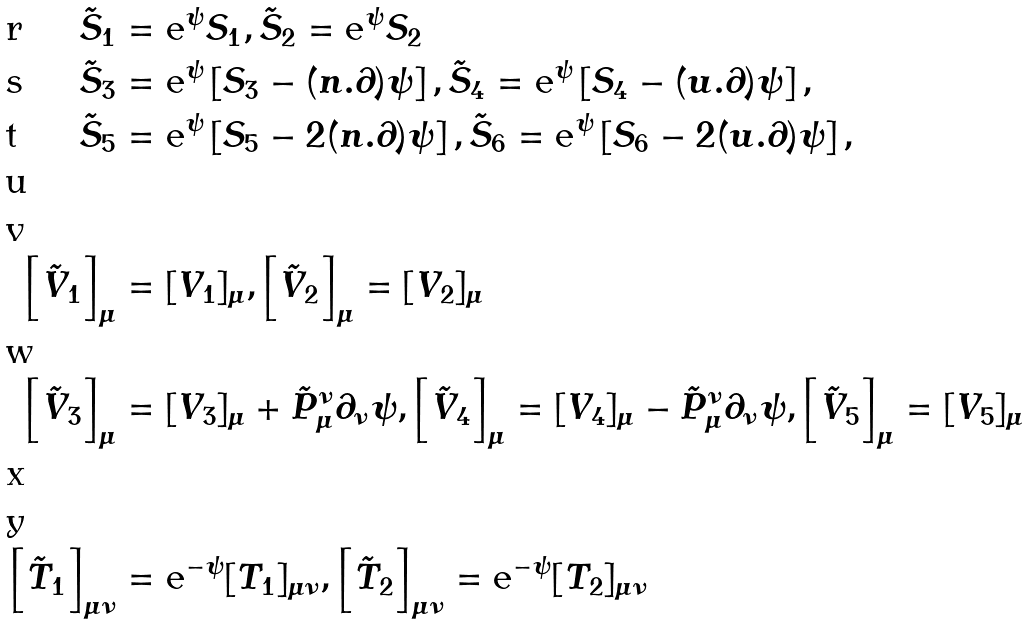Convert formula to latex. <formula><loc_0><loc_0><loc_500><loc_500>\tilde { S } _ { 1 } & = \text {e} ^ { \psi } S _ { 1 } , \tilde { S } _ { 2 } = \text {e} ^ { \psi } S _ { 2 } \\ \tilde { S } _ { 3 } & = \text {e} ^ { \psi } \left [ S _ { 3 } - ( n . \partial ) \psi \right ] , \tilde { S } _ { 4 } = \text {e} ^ { \psi } \left [ S _ { 4 } - ( u . \partial ) \psi \right ] , \\ \tilde { S } _ { 5 } & = \text {e} ^ { \psi } \left [ S _ { 5 } - 2 ( n . \partial ) \psi \right ] , \tilde { S } _ { 6 } = \text {e} ^ { \psi } \left [ S _ { 6 } - 2 ( u . \partial ) \psi \right ] , \\ \\ \left [ \tilde { V } _ { 1 } \right ] _ { \mu } & = [ V _ { 1 } ] _ { \mu } , \left [ \tilde { V } _ { 2 } \right ] _ { \mu } = [ V _ { 2 } ] _ { \mu } \\ \left [ \tilde { V } _ { 3 } \right ] _ { \mu } & = [ V _ { 3 } ] _ { \mu } + \tilde { P } ^ { \nu } _ { \mu } \partial _ { \nu } \psi , \left [ \tilde { V } _ { 4 } \right ] _ { \mu } = [ V _ { 4 } ] _ { \mu } - \tilde { P } ^ { \nu } _ { \mu } \partial _ { \nu } \psi , \left [ \tilde { V } _ { 5 } \right ] _ { \mu } = [ V _ { 5 } ] _ { \mu } \\ \\ \left [ \tilde { T } _ { 1 } \right ] _ { \mu \nu } & = \text {e} ^ { - \psi } [ T _ { 1 } ] _ { \mu \nu } , \left [ \tilde { T } _ { 2 } \right ] _ { \mu \nu } = \text {e} ^ { - \psi } [ T _ { 2 } ] _ { \mu \nu } \</formula> 